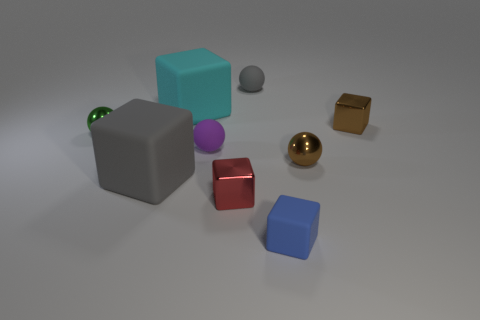Subtract all small rubber blocks. How many blocks are left? 4 Subtract all gray cubes. How many cubes are left? 4 Subtract 3 cubes. How many cubes are left? 2 Subtract all blue balls. Subtract all brown cylinders. How many balls are left? 4 Subtract all blocks. How many objects are left? 4 Add 5 big gray things. How many big gray things are left? 6 Add 2 brown rubber blocks. How many brown rubber blocks exist? 2 Subtract 0 yellow blocks. How many objects are left? 9 Subtract all big cyan metal balls. Subtract all shiny blocks. How many objects are left? 7 